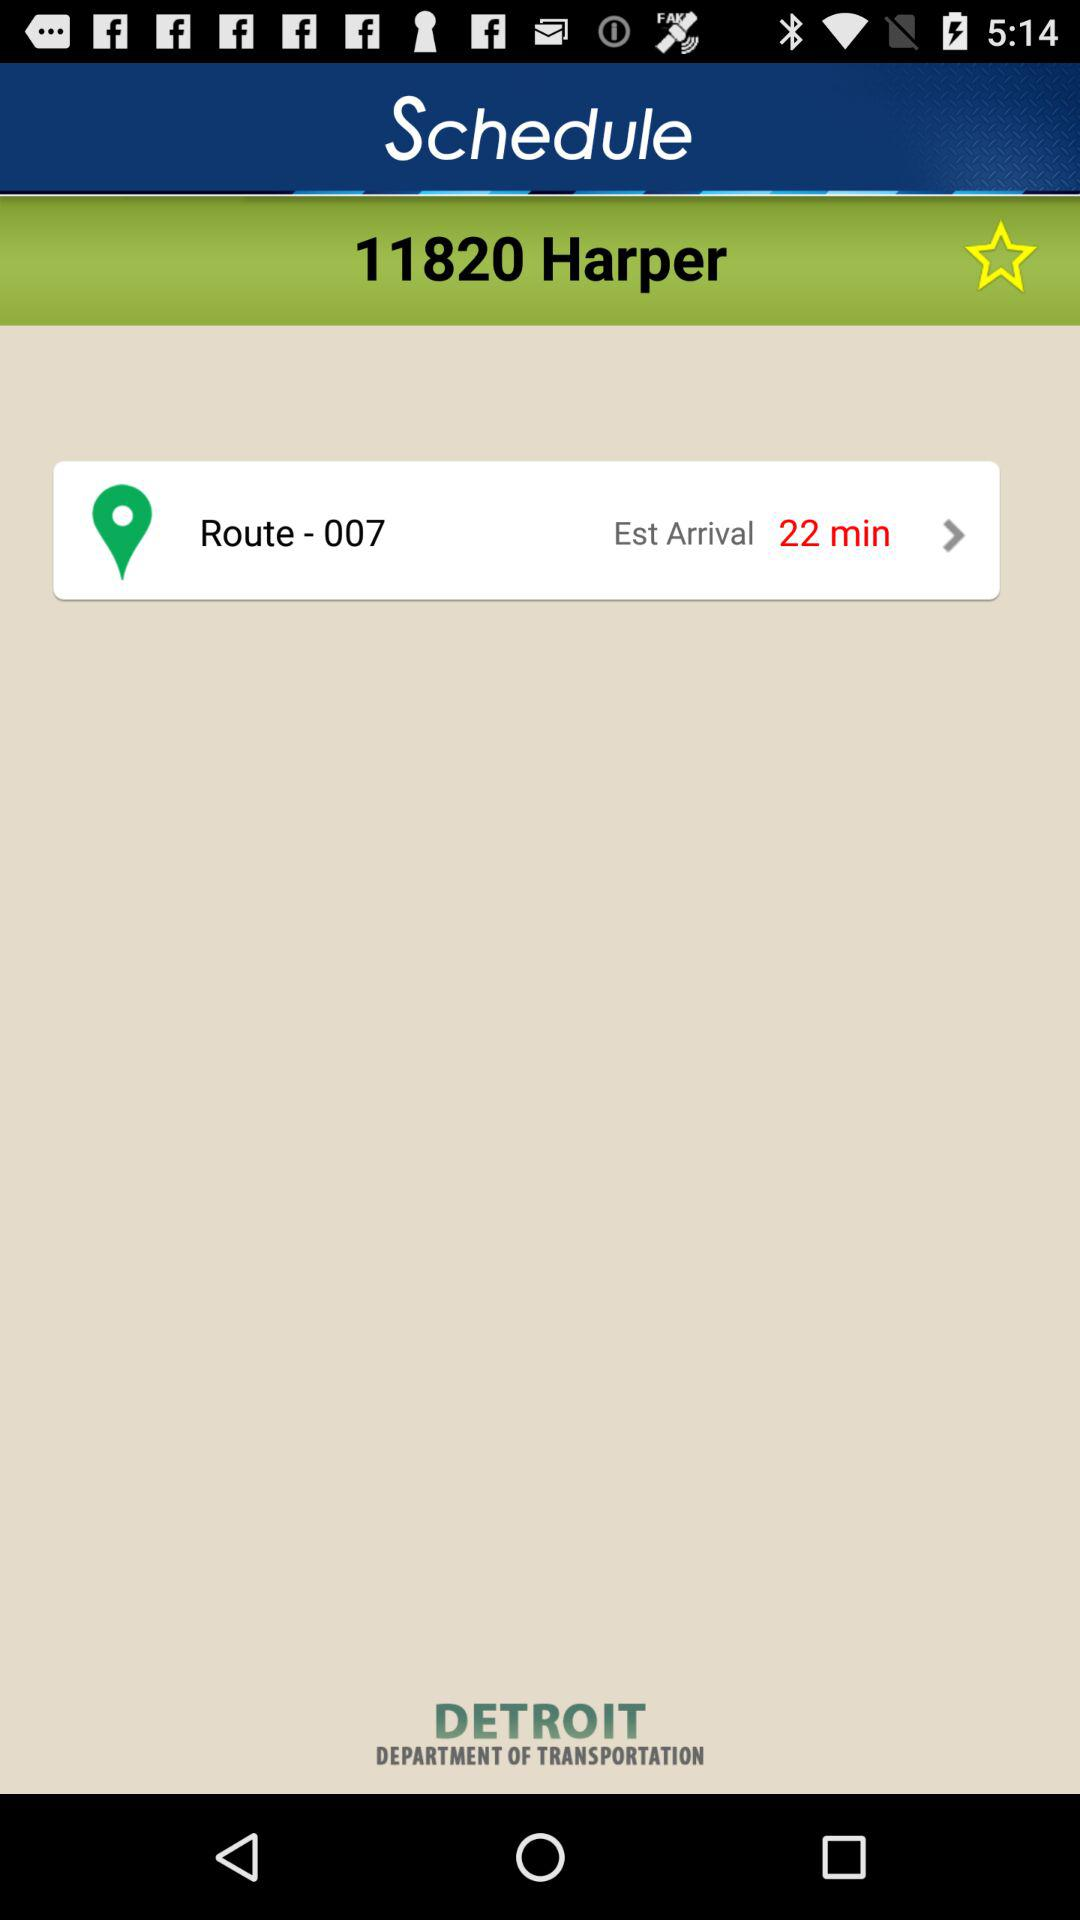What is the name of the department of transportation? The name of the department of transportation is Detroit. 